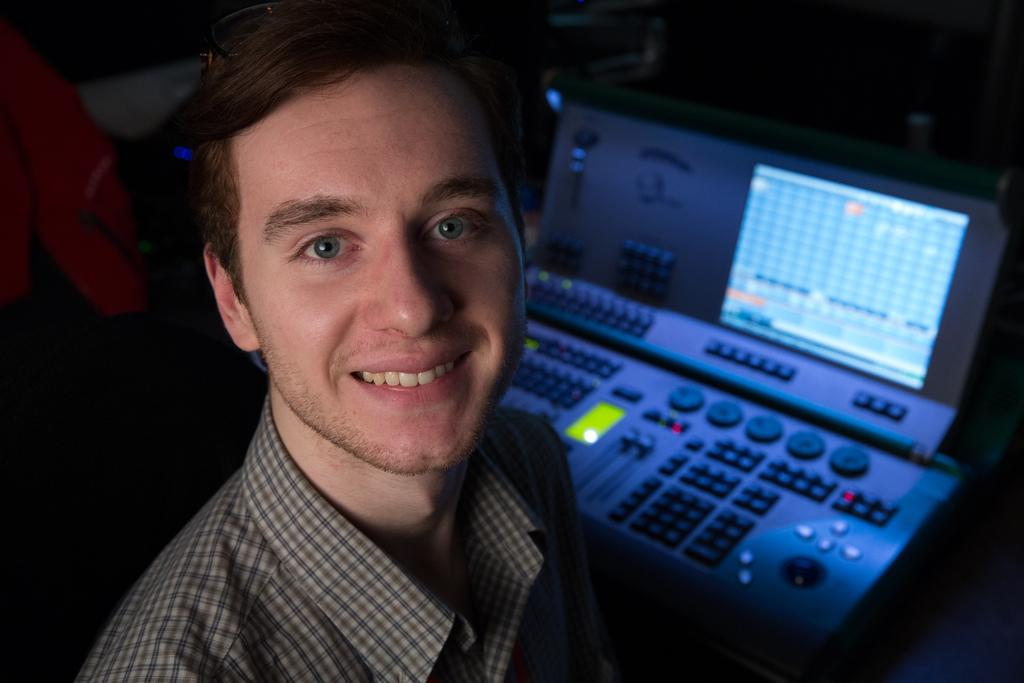What is the main subject of the image? There is a person in the image. What is the person's facial expression? The person is smiling. What type of clothing is the person wearing? The person is wearing a shirt. What electronic device can be seen in the image? There is an electronic device with control buttons and a display in the image. How would you describe the background of the image? The background of the image appears blurry. What type of carriage is being used to transport the oven in the image? There is no carriage or oven present in the image; it features a person, an electronic device, and a blurry background. 